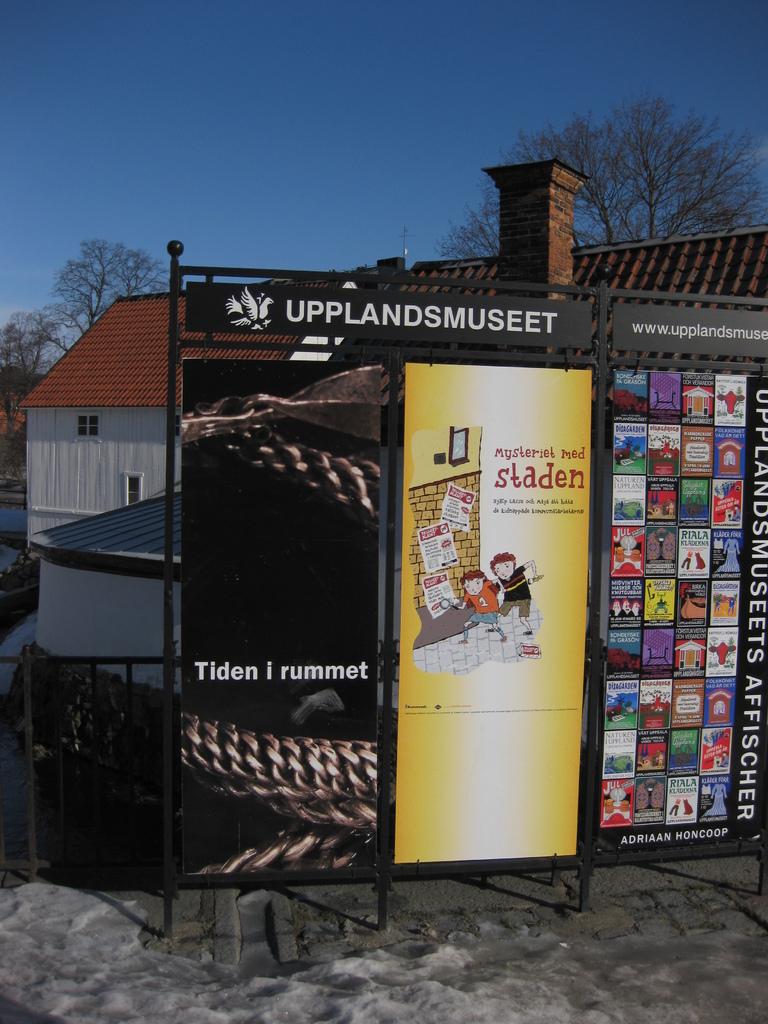What is the name of the location written on the board's banner?
Make the answer very short. Upplandsmuseet. 